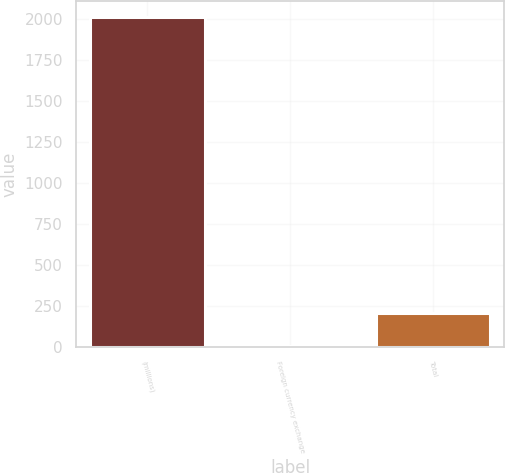<chart> <loc_0><loc_0><loc_500><loc_500><bar_chart><fcel>(millions)<fcel>Foreign currency exchange<fcel>Total<nl><fcel>2011<fcel>6<fcel>206.5<nl></chart> 